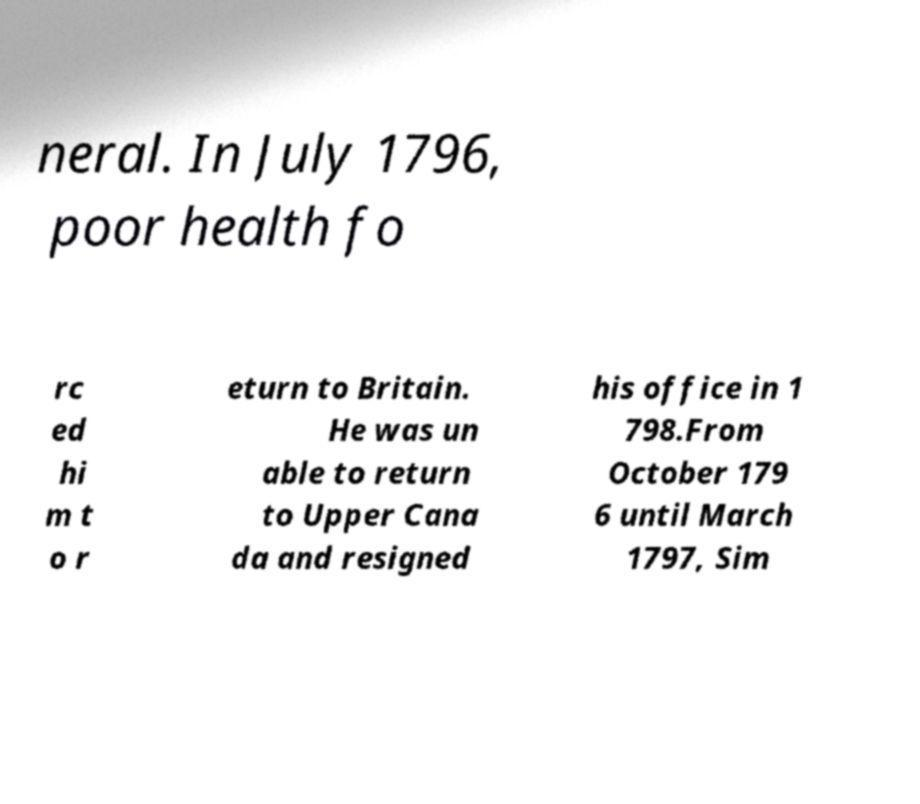For documentation purposes, I need the text within this image transcribed. Could you provide that? neral. In July 1796, poor health fo rc ed hi m t o r eturn to Britain. He was un able to return to Upper Cana da and resigned his office in 1 798.From October 179 6 until March 1797, Sim 